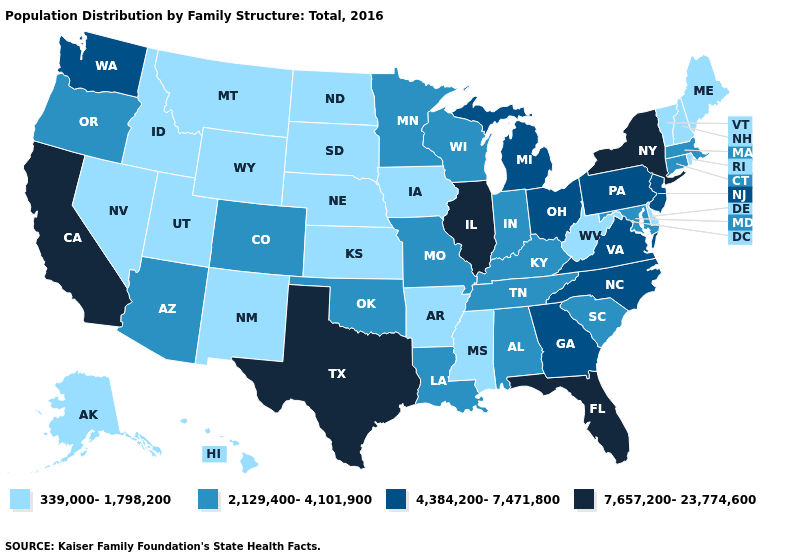Name the states that have a value in the range 7,657,200-23,774,600?
Answer briefly. California, Florida, Illinois, New York, Texas. Does the first symbol in the legend represent the smallest category?
Answer briefly. Yes. Which states have the lowest value in the Northeast?
Write a very short answer. Maine, New Hampshire, Rhode Island, Vermont. Is the legend a continuous bar?
Keep it brief. No. Name the states that have a value in the range 339,000-1,798,200?
Concise answer only. Alaska, Arkansas, Delaware, Hawaii, Idaho, Iowa, Kansas, Maine, Mississippi, Montana, Nebraska, Nevada, New Hampshire, New Mexico, North Dakota, Rhode Island, South Dakota, Utah, Vermont, West Virginia, Wyoming. Does Montana have the lowest value in the West?
Write a very short answer. Yes. Name the states that have a value in the range 4,384,200-7,471,800?
Answer briefly. Georgia, Michigan, New Jersey, North Carolina, Ohio, Pennsylvania, Virginia, Washington. What is the value of Arizona?
Answer briefly. 2,129,400-4,101,900. What is the highest value in the USA?
Give a very brief answer. 7,657,200-23,774,600. Does the map have missing data?
Answer briefly. No. Name the states that have a value in the range 4,384,200-7,471,800?
Quick response, please. Georgia, Michigan, New Jersey, North Carolina, Ohio, Pennsylvania, Virginia, Washington. What is the value of Wisconsin?
Keep it brief. 2,129,400-4,101,900. What is the value of Alaska?
Answer briefly. 339,000-1,798,200. Which states have the lowest value in the USA?
Concise answer only. Alaska, Arkansas, Delaware, Hawaii, Idaho, Iowa, Kansas, Maine, Mississippi, Montana, Nebraska, Nevada, New Hampshire, New Mexico, North Dakota, Rhode Island, South Dakota, Utah, Vermont, West Virginia, Wyoming. What is the value of Oregon?
Short answer required. 2,129,400-4,101,900. 